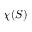Convert formula to latex. <formula><loc_0><loc_0><loc_500><loc_500>\chi ( S )</formula> 